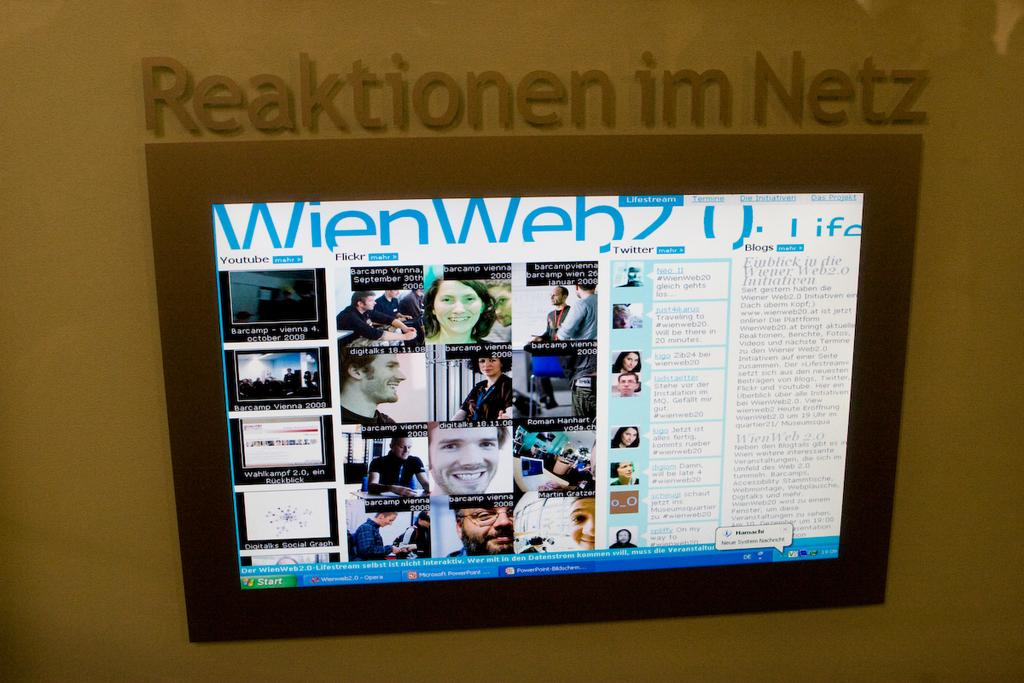<image>
Render a clear and concise summary of the photo. a turned on screen underneath a label that says 'reaktionen im netz' 